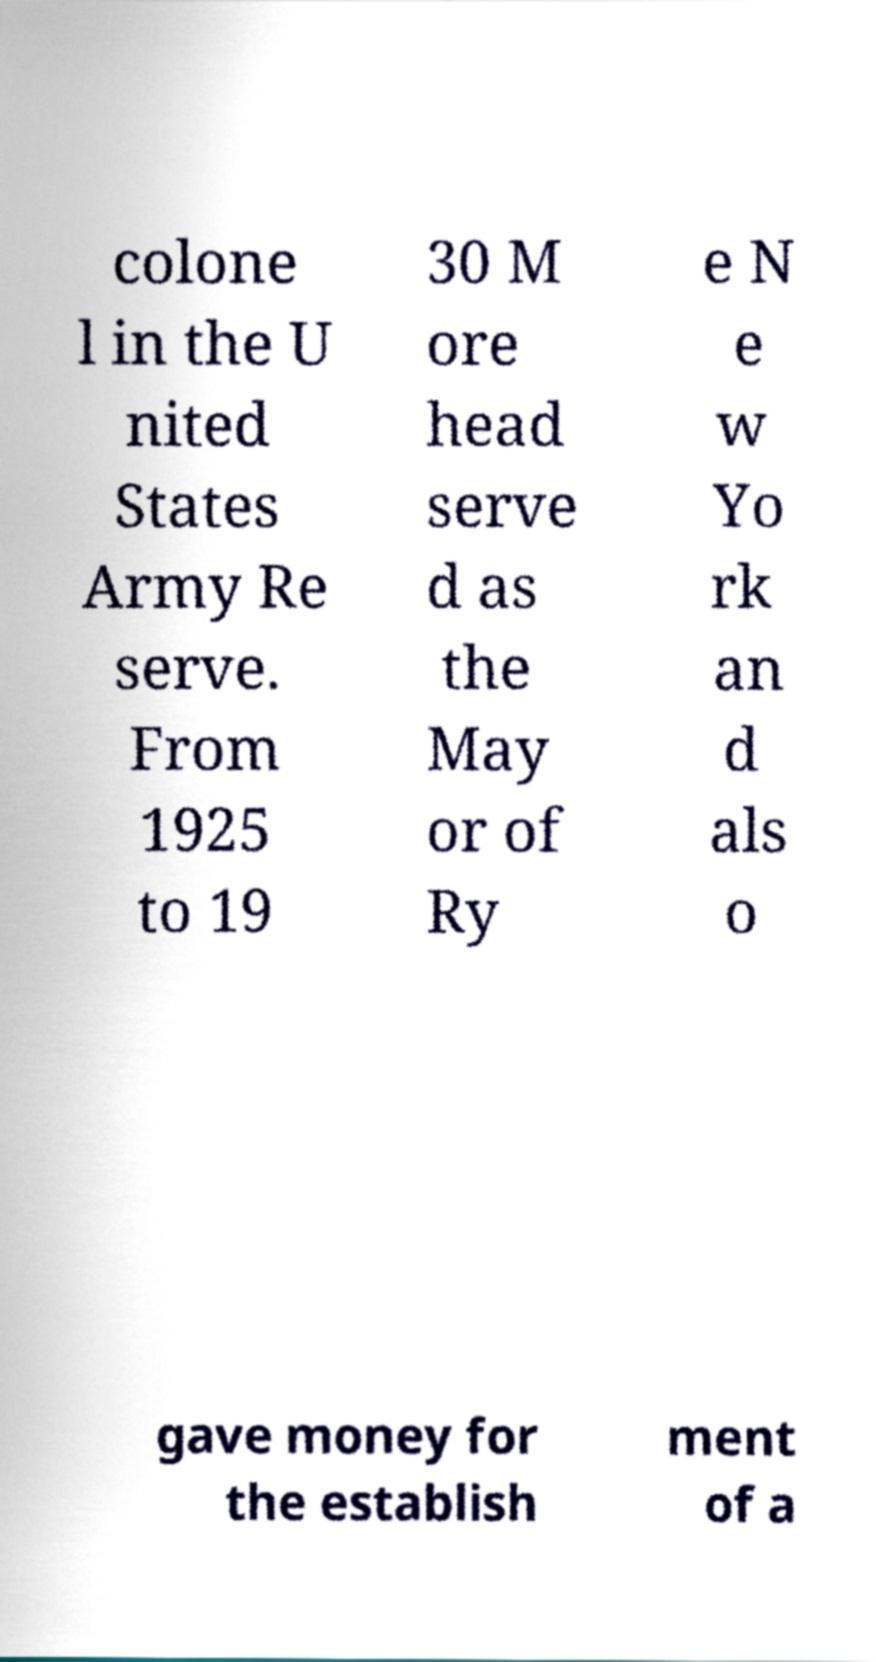For documentation purposes, I need the text within this image transcribed. Could you provide that? colone l in the U nited States Army Re serve. From 1925 to 19 30 M ore head serve d as the May or of Ry e N e w Yo rk an d als o gave money for the establish ment of a 